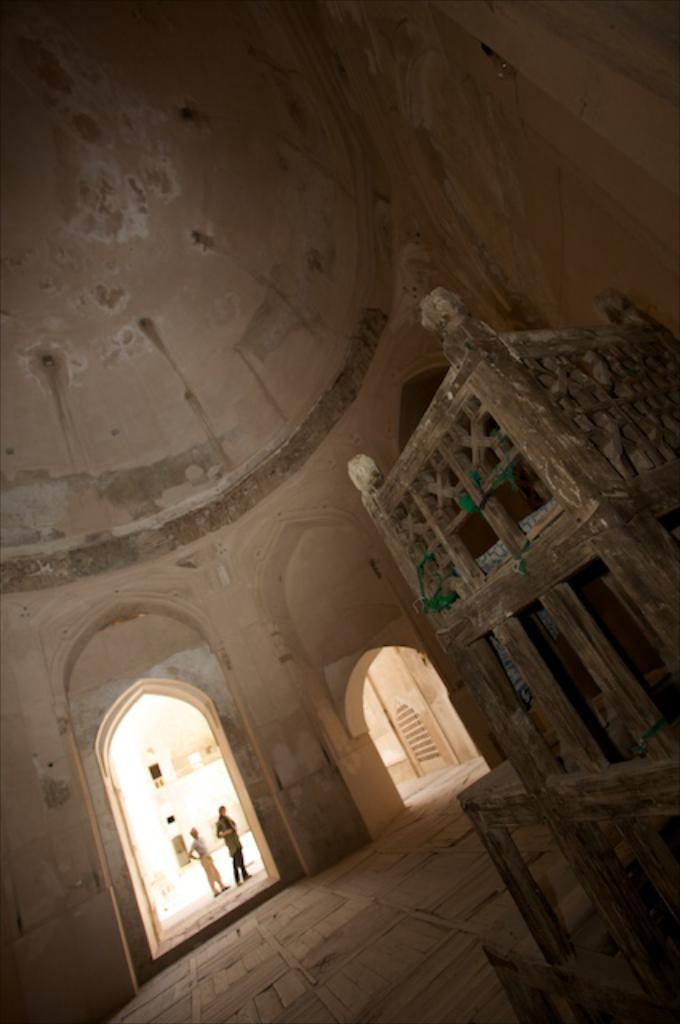Where was the image taken? The image was taken inside a tomb. Can you describe the people in the image? There are two persons near the entrance of the tomb. What can be seen on the right side of the image? There is a wooden object on the right side of the image. What type of copper material can be seen on the pig in the image? There is no pig or copper material present in the image. 